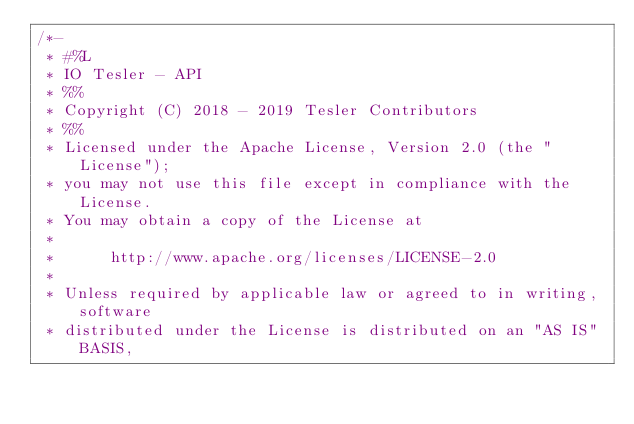Convert code to text. <code><loc_0><loc_0><loc_500><loc_500><_Java_>/*-
 * #%L
 * IO Tesler - API
 * %%
 * Copyright (C) 2018 - 2019 Tesler Contributors
 * %%
 * Licensed under the Apache License, Version 2.0 (the "License");
 * you may not use this file except in compliance with the License.
 * You may obtain a copy of the License at
 *
 *      http://www.apache.org/licenses/LICENSE-2.0
 *
 * Unless required by applicable law or agreed to in writing, software
 * distributed under the License is distributed on an "AS IS" BASIS,</code> 